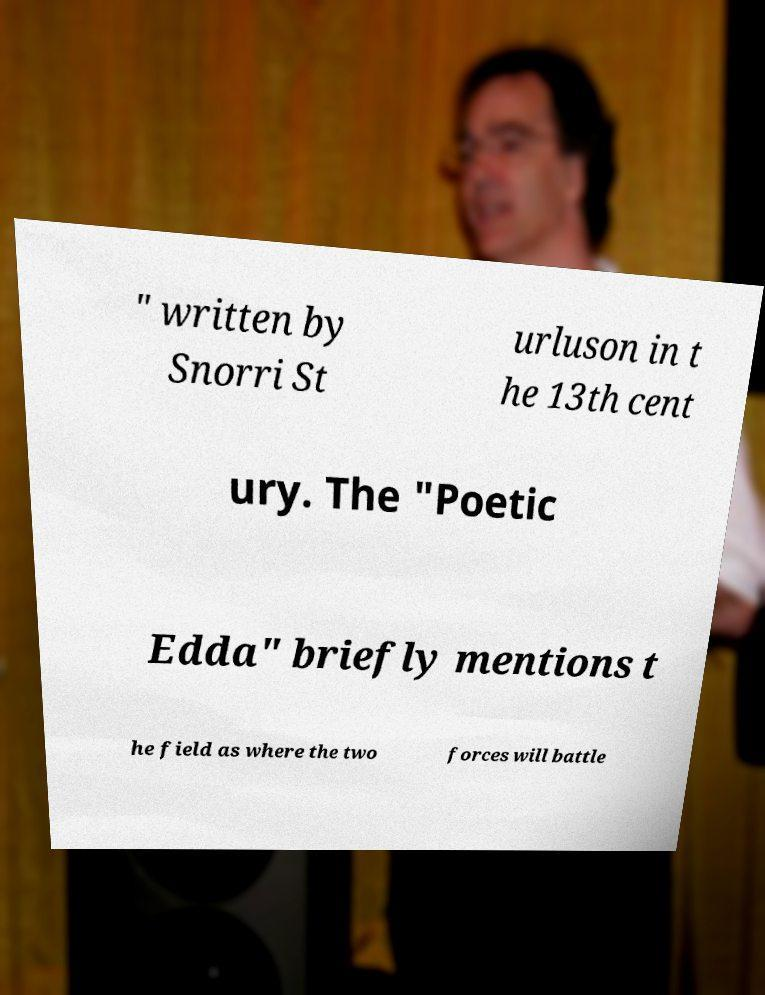Please read and relay the text visible in this image. What does it say? " written by Snorri St urluson in t he 13th cent ury. The "Poetic Edda" briefly mentions t he field as where the two forces will battle 